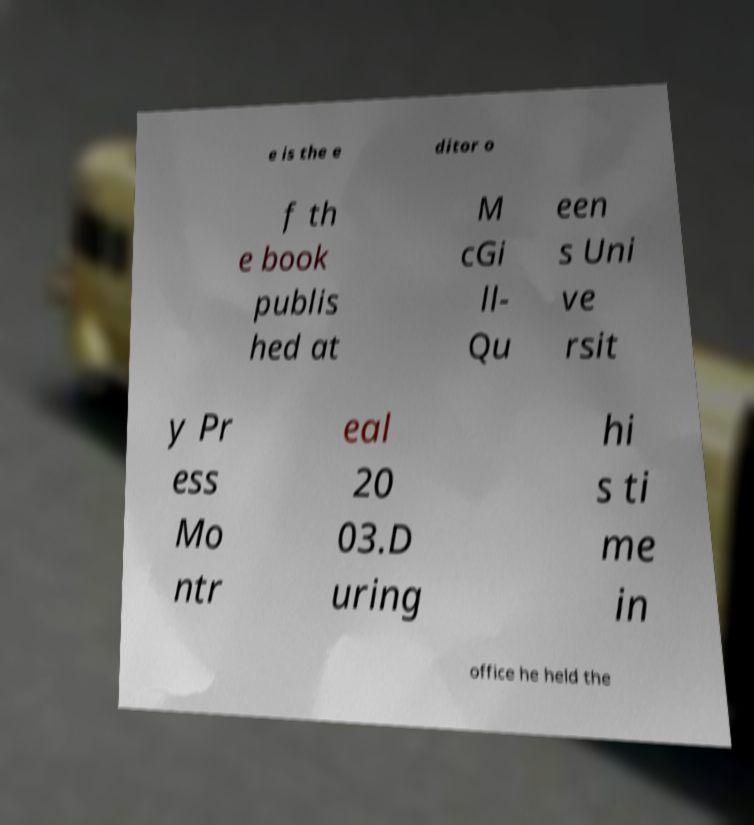Please read and relay the text visible in this image. What does it say? e is the e ditor o f th e book publis hed at M cGi ll- Qu een s Uni ve rsit y Pr ess Mo ntr eal 20 03.D uring hi s ti me in office he held the 